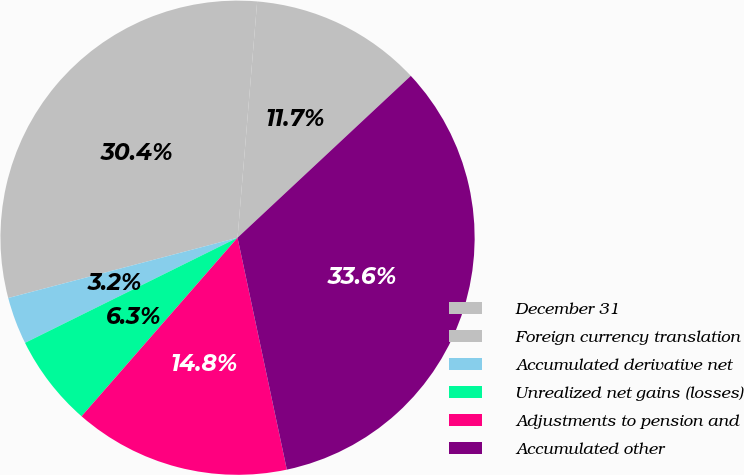Convert chart to OTSL. <chart><loc_0><loc_0><loc_500><loc_500><pie_chart><fcel>December 31<fcel>Foreign currency translation<fcel>Accumulated derivative net<fcel>Unrealized net gains (losses)<fcel>Adjustments to pension and<fcel>Accumulated other<nl><fcel>11.72%<fcel>30.41%<fcel>3.22%<fcel>6.26%<fcel>14.76%<fcel>33.62%<nl></chart> 